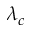<formula> <loc_0><loc_0><loc_500><loc_500>\lambda _ { c }</formula> 